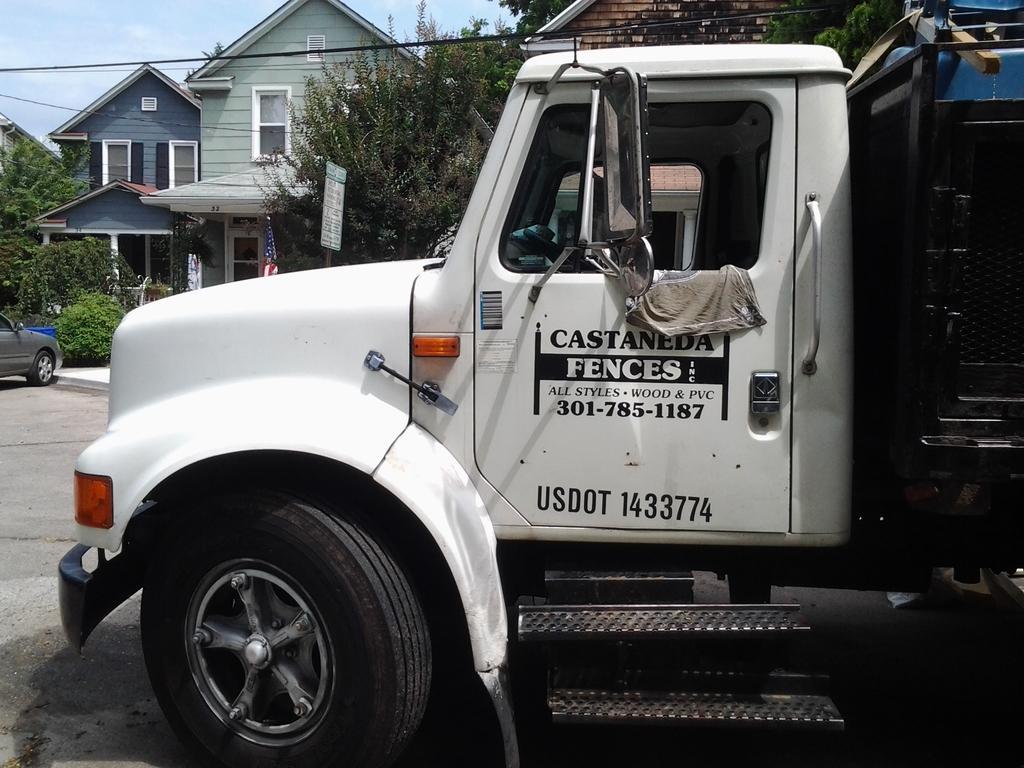Describe this image in one or two sentences. In this image, we can see vehicles on the road and in the background, there are buildings, trees, boards, wires and we can see a flag and some bushes. At the top, there is sky. 